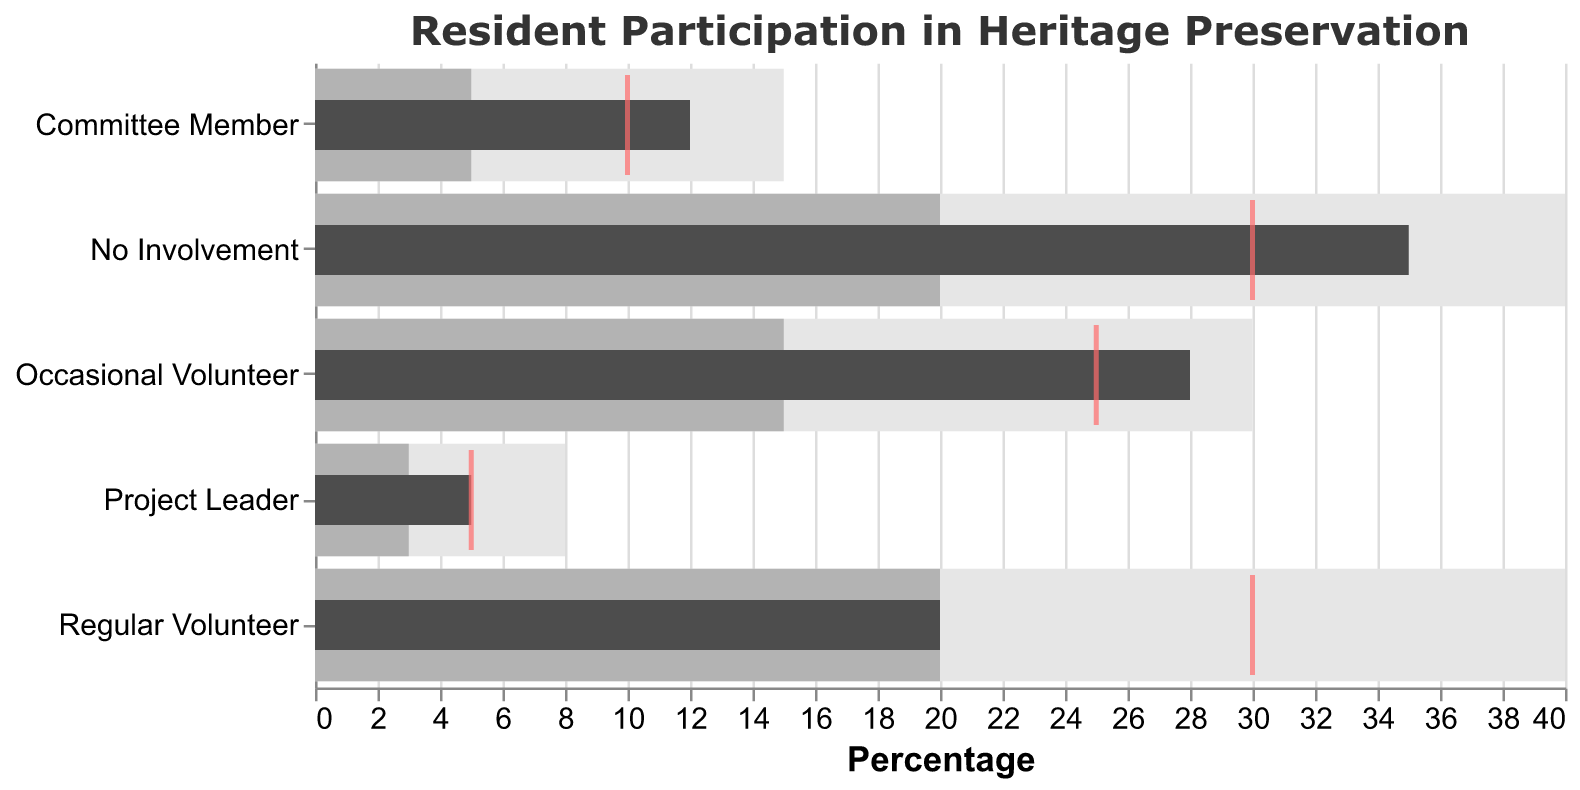What is the title of the figure? The title is displayed at the top of the figure. It provides a summary of what the chart represents.
Answer: Resident Participation in Heritage Preservation Which category of residents has the highest percentage of actual involvement? By looking at the length of the darkest bars (Actual values), we can see that the "No Involvement" category has the longest bar, indicating the highest percentage of actual involvement.
Answer: No Involvement What is the medium range percentage for the "Regular Volunteer" category? The medium range percentage can be found in the second bar (lighter shade) for the "Regular Volunteer" category. The value is marked as 20%.
Answer: 20 Is the actual involvement of "Committee Member" residents above or below their target? The actual involvement percentage (dark bar) for "Committee Member" is 12%. The target involvement (red tick) is 10%. Since 12% is greater than 10%, the actual involvement is above the target.
Answer: Above Which category has its actual involvement exactly meeting the target? The category where the actual bar (dark) aligns perfectly with the red tick is "Project Leader," both at 5%.
Answer: Project Leader Calculate the difference between the actual and target percentages for "Occasional Volunteer". The actual percentage is 28%, and the target is 25%. Subtraction gives us 28% - 25% = 3%.
Answer: 3% Among all categories, which one has the smallest high range percentage? Comparing the length of the lightest bars (high range), "Project Leader" has the smallest high range at 8%.
Answer: Project Leader What is the total of all target percentages across all categories? The target percentages are 30, 25, 30, 10, and 5. Summing these up: 30 + 25 + 30 + 10 + 5 = 100%.
Answer: 100% How many categories have actual percentages higher than their target percentages? By comparing actual and target percentages for each category, we find that "No Involvement" (35 > 30), "Occasional Volunteer" (28 > 25), and "Committee Member" (12 > 10) have higher actual values. This results in 3 categories.
Answer: 3 